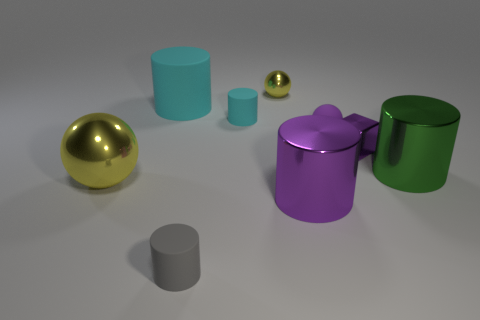What is the largest object in the image? The largest object in the image is the gold-colored sphere on the left side. What can you tell me about the various finishes of the objects? The objects display a range of finishes: the gold and smaller green sphere have a shiny metallic finish, while the cylinders and the purple object with a star-shaped lid have a matte appearance. 